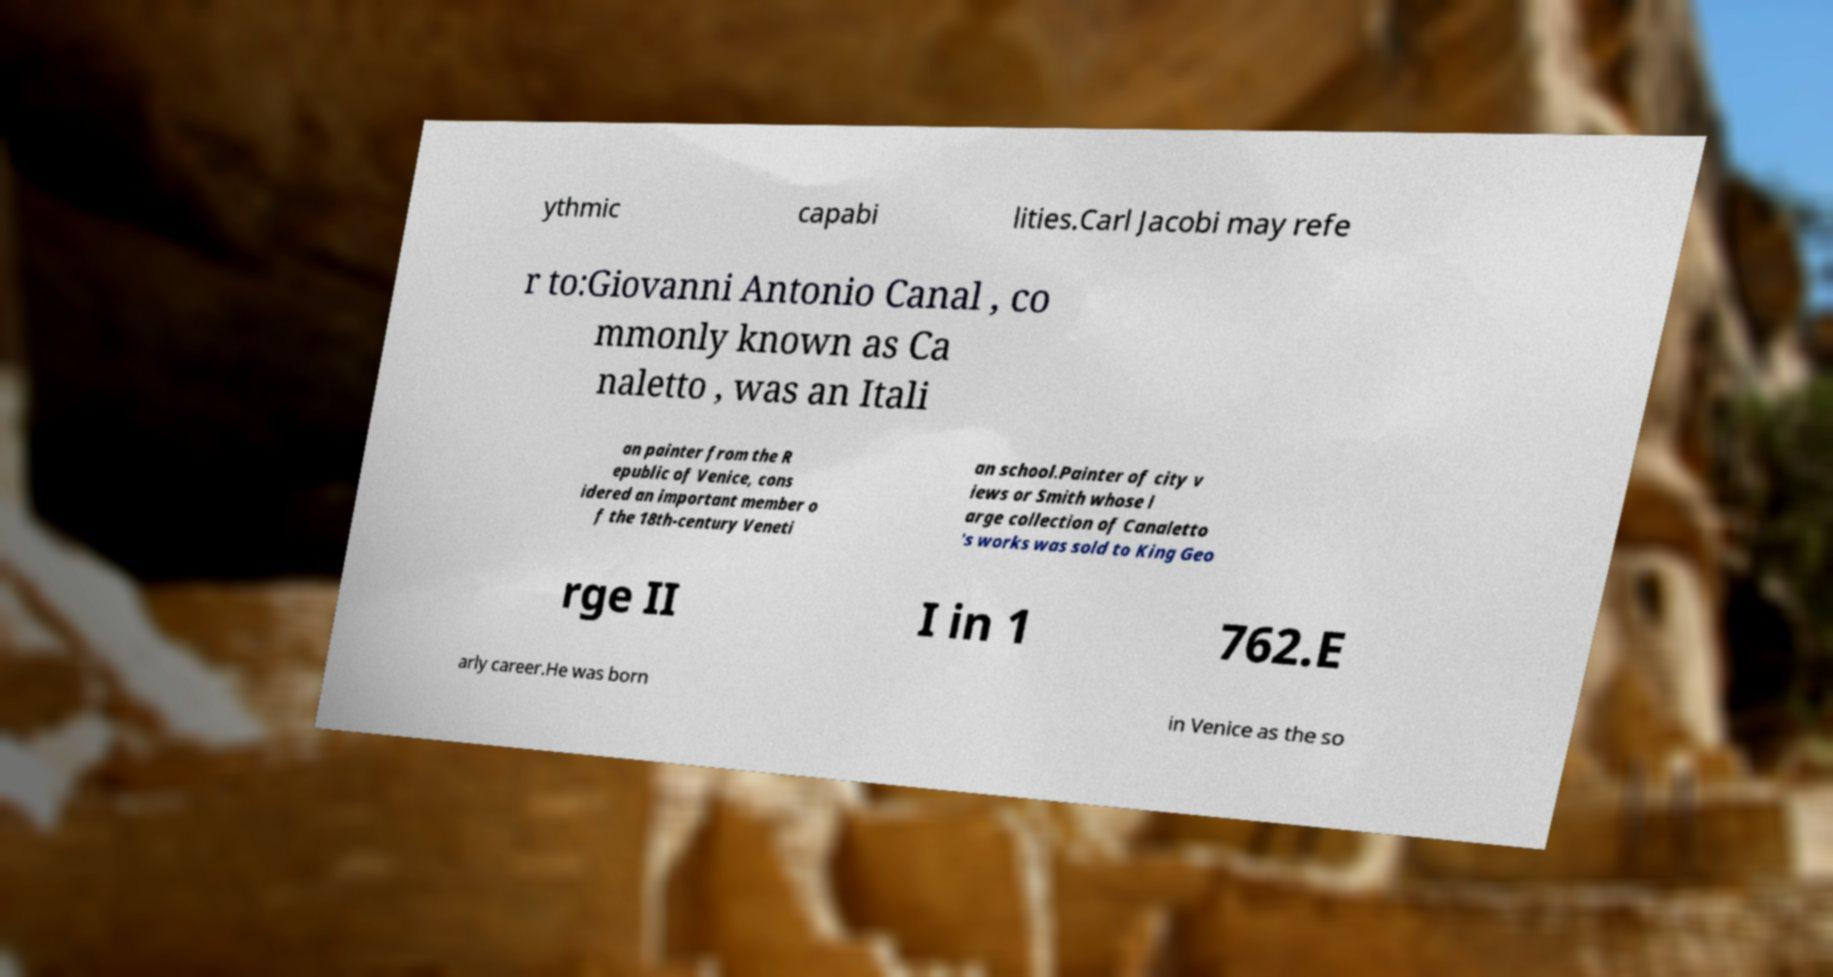There's text embedded in this image that I need extracted. Can you transcribe it verbatim? ythmic capabi lities.Carl Jacobi may refe r to:Giovanni Antonio Canal , co mmonly known as Ca naletto , was an Itali an painter from the R epublic of Venice, cons idered an important member o f the 18th-century Veneti an school.Painter of city v iews or Smith whose l arge collection of Canaletto 's works was sold to King Geo rge II I in 1 762.E arly career.He was born in Venice as the so 